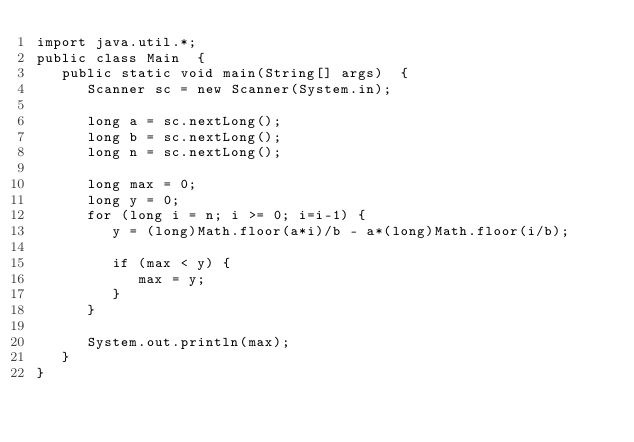<code> <loc_0><loc_0><loc_500><loc_500><_Java_>import java.util.*;
public class Main  {
   public static void main(String[] args)  {
      Scanner sc = new Scanner(System.in);
      
      long a = sc.nextLong();
      long b = sc.nextLong();
      long n = sc.nextLong();
      
      long max = 0;
      long y = 0;
      for (long i = n; i >= 0; i=i-1) {
         y = (long)Math.floor(a*i)/b - a*(long)Math.floor(i/b);
         
         if (max < y) {
            max = y;
         }   
      }
      
      System.out.println(max);
   }
}
</code> 